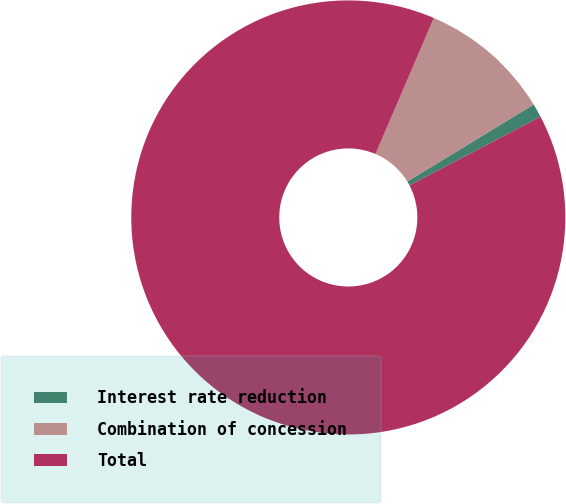Convert chart. <chart><loc_0><loc_0><loc_500><loc_500><pie_chart><fcel>Interest rate reduction<fcel>Combination of concession<fcel>Total<nl><fcel>1.03%<fcel>9.84%<fcel>89.14%<nl></chart> 